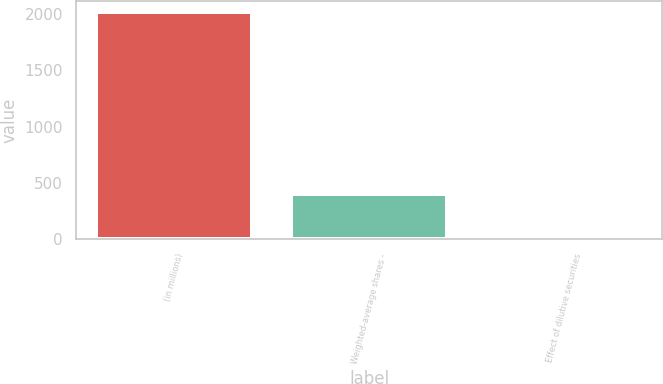Convert chart to OTSL. <chart><loc_0><loc_0><loc_500><loc_500><bar_chart><fcel>(in millions)<fcel>Weighted-average shares -<fcel>Effect of dilutive securities<nl><fcel>2013<fcel>404.28<fcel>2.1<nl></chart> 